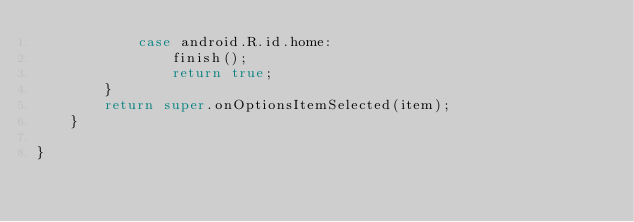Convert code to text. <code><loc_0><loc_0><loc_500><loc_500><_Java_>            case android.R.id.home:
                finish();
                return true;
        }
        return super.onOptionsItemSelected(item);
    }

}
</code> 